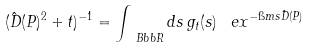Convert formula to latex. <formula><loc_0><loc_0><loc_500><loc_500>( \hat { D } ( P ) ^ { 2 } + t ) ^ { - 1 } = \int _ { \ B b b R } d s \, g _ { t } ( s ) \, \ e x ^ { - \i m s \hat { D } ( P ) }</formula> 